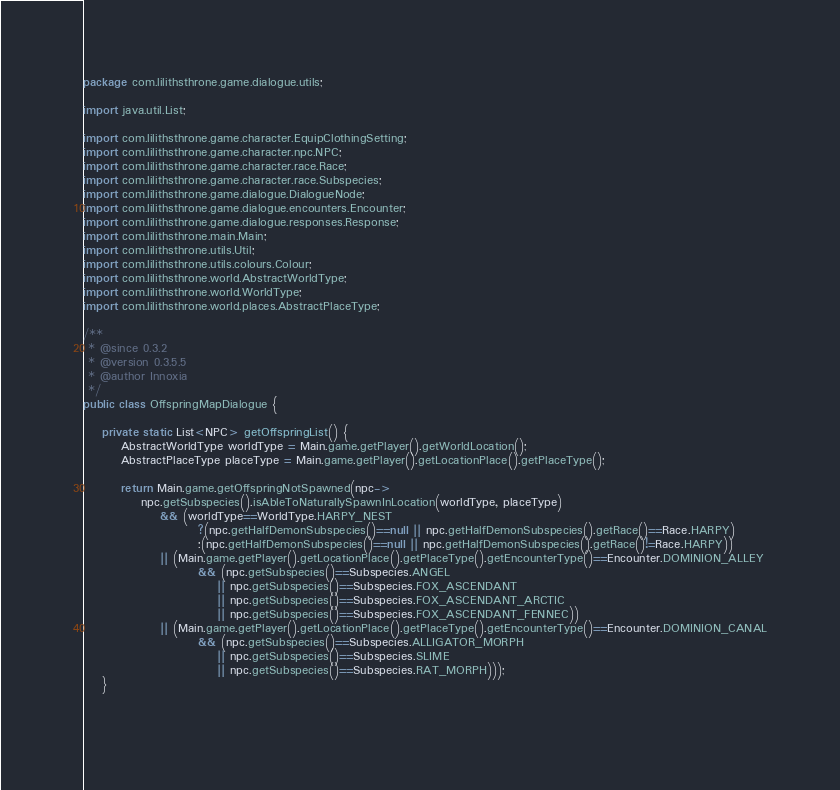Convert code to text. <code><loc_0><loc_0><loc_500><loc_500><_Java_>package com.lilithsthrone.game.dialogue.utils;

import java.util.List;

import com.lilithsthrone.game.character.EquipClothingSetting;
import com.lilithsthrone.game.character.npc.NPC;
import com.lilithsthrone.game.character.race.Race;
import com.lilithsthrone.game.character.race.Subspecies;
import com.lilithsthrone.game.dialogue.DialogueNode;
import com.lilithsthrone.game.dialogue.encounters.Encounter;
import com.lilithsthrone.game.dialogue.responses.Response;
import com.lilithsthrone.main.Main;
import com.lilithsthrone.utils.Util;
import com.lilithsthrone.utils.colours.Colour;
import com.lilithsthrone.world.AbstractWorldType;
import com.lilithsthrone.world.WorldType;
import com.lilithsthrone.world.places.AbstractPlaceType;

/**
 * @since 0.3.2
 * @version 0.3.5.5
 * @author Innoxia
 */
public class OffspringMapDialogue {
	
	private static List<NPC> getOffspringList() {
		AbstractWorldType worldType = Main.game.getPlayer().getWorldLocation();
		AbstractPlaceType placeType = Main.game.getPlayer().getLocationPlace().getPlaceType();
		
		return Main.game.getOffspringNotSpawned(npc->
			npc.getSubspecies().isAbleToNaturallySpawnInLocation(worldType, placeType)
				&& (worldType==WorldType.HARPY_NEST
						?(npc.getHalfDemonSubspecies()==null || npc.getHalfDemonSubspecies().getRace()==Race.HARPY)
						:(npc.getHalfDemonSubspecies()==null || npc.getHalfDemonSubspecies().getRace()!=Race.HARPY))
				|| (Main.game.getPlayer().getLocationPlace().getPlaceType().getEncounterType()==Encounter.DOMINION_ALLEY
						&& (npc.getSubspecies()==Subspecies.ANGEL
							|| npc.getSubspecies()==Subspecies.FOX_ASCENDANT
							|| npc.getSubspecies()==Subspecies.FOX_ASCENDANT_ARCTIC
							|| npc.getSubspecies()==Subspecies.FOX_ASCENDANT_FENNEC))
				|| (Main.game.getPlayer().getLocationPlace().getPlaceType().getEncounterType()==Encounter.DOMINION_CANAL
						&& (npc.getSubspecies()==Subspecies.ALLIGATOR_MORPH
							|| npc.getSubspecies()==Subspecies.SLIME
							|| npc.getSubspecies()==Subspecies.RAT_MORPH)));
	}
	
	</code> 